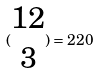<formula> <loc_0><loc_0><loc_500><loc_500>( \begin{matrix} 1 2 \\ 3 \end{matrix} ) = 2 2 0</formula> 